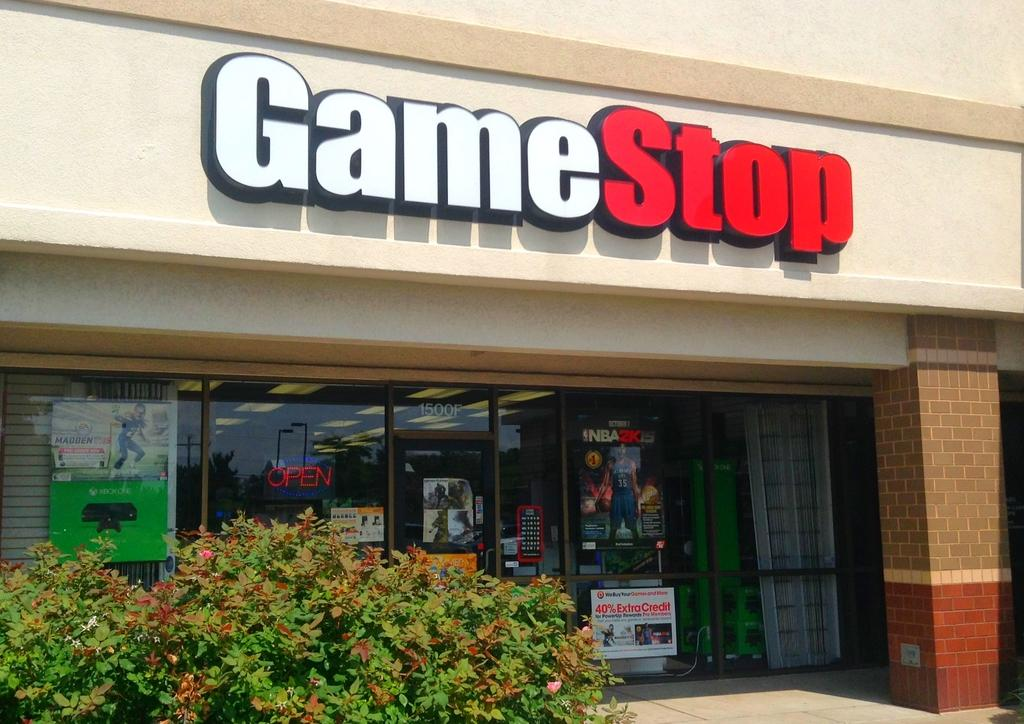What is the main structure in the center of the image? There is a building in the center of the image. What type of natural elements can be seen in the image? There are plants in the image. What is the flat, rectangular object in the image? There is a board in the image. What type of printed materials are present in the image? There are posters in the image. What surface is visible at the bottom of the image? There is a floor visible at the bottom of the image. What type of cloud is present in the image? There is no cloud present in the image. How does the board compare to the building in the image? The board and the building are separate objects in the image and cannot be compared directly. 